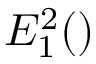Convert formula to latex. <formula><loc_0><loc_0><loc_500><loc_500>E _ { 1 } ^ { 2 } ( \ v r )</formula> 